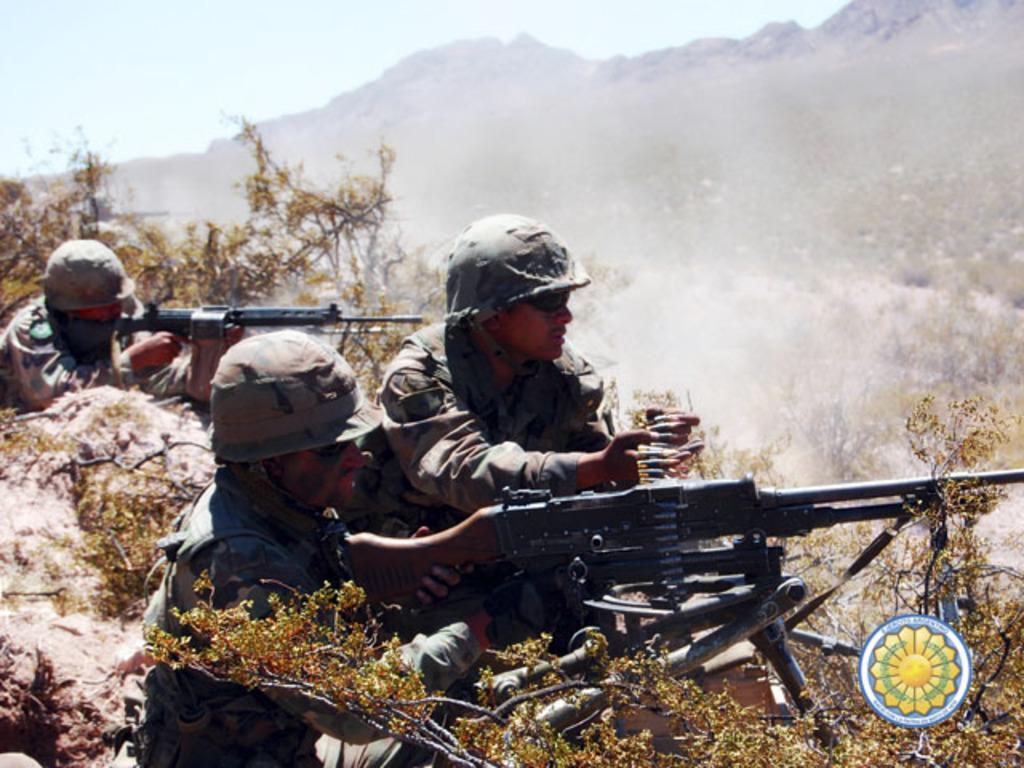In one or two sentences, can you explain what this image depicts? In this image I can see three people with military uniforms. I can see two people are holding the guns and one person is holding the bullets. To the side of these people I can see the rocks and plants. In the background I can see the mountains and the sky. 